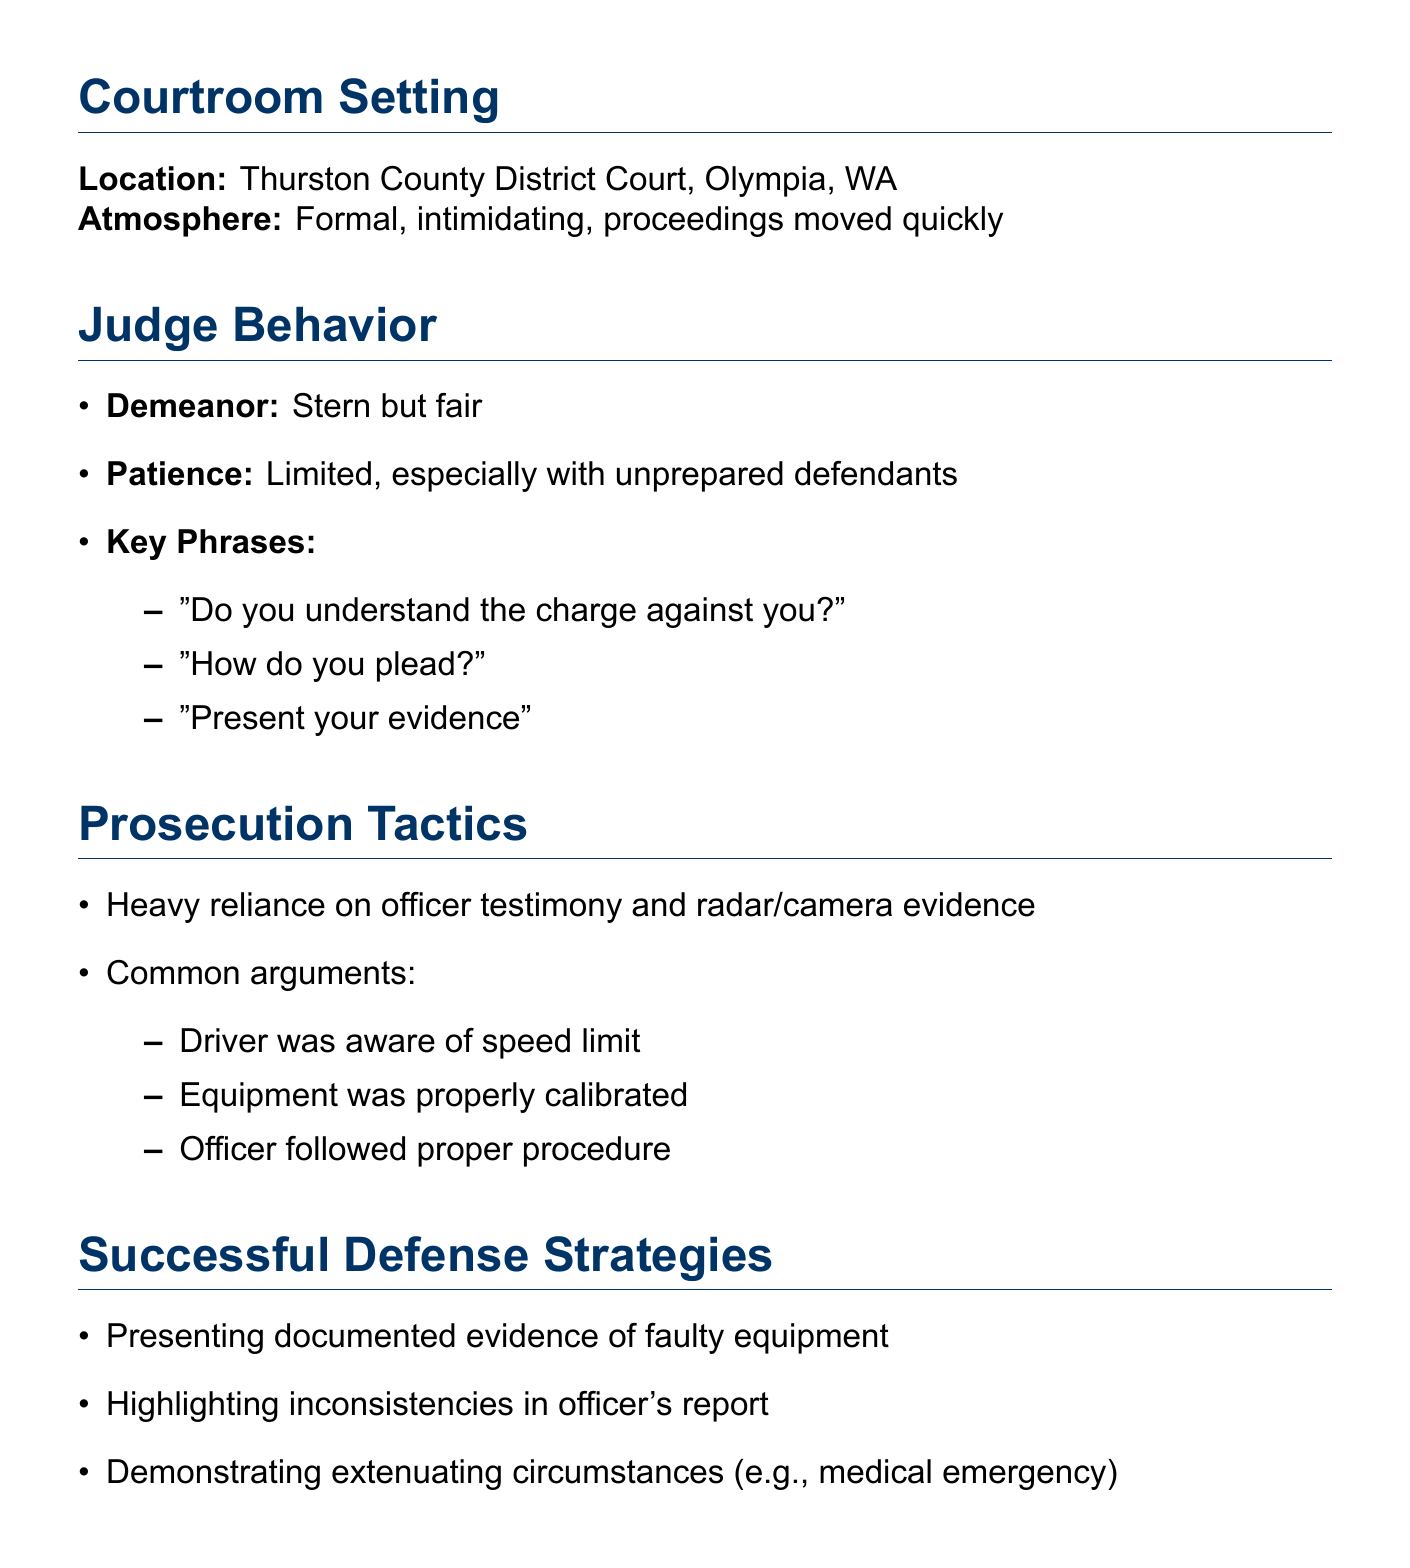What is the location of the court? The location mentioned in the document is Thurston County District Court, Olympia, WA.
Answer: Thurston County District Court, Olympia, WA What is the court atmosphere described as? The atmosphere of the courtroom is described as formal and intimidating, with proceedings moving quickly.
Answer: Formal, intimidating What demeanor does the judge exhibit? The demeanor of the judge is described in the notes, highlighting that he is stern but fair.
Answer: Stern but fair What is a common argument used by the prosecution? One common argument presented by the prosecution is that the driver was aware of the speed limit.
Answer: Driver was aware of speed limit What is one successful defense strategy mentioned? Presenting documented evidence of faulty equipment is identified as one successful defense strategy.
Answer: Presenting documented evidence of faulty equipment What is a common mistake made by self-represented defendants? A lack of preparation is noted as a common mistake among self-represented defendants.
Answer: Lack of preparation How long before the scheduled time should defendants check in? The document states that defendants are required to check in with the clerk 15 minutes before their scheduled time.
Answer: 15 minutes What is one potential outcome of the court proceedings? One of the potential outcomes listed is a case dismissed.
Answer: Case dismissed What is a key phrase the judge might say? A key phrase that the judge might say during the proceedings is "How do you plead?"
Answer: How do you plead? 